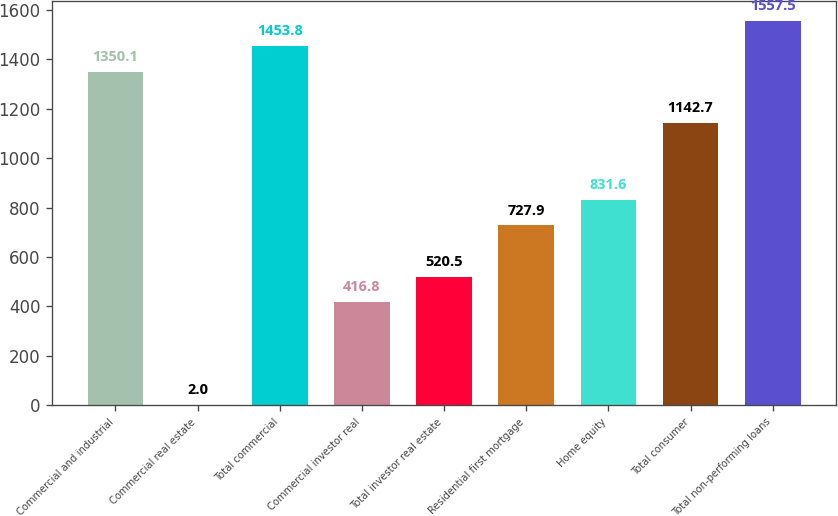Convert chart. <chart><loc_0><loc_0><loc_500><loc_500><bar_chart><fcel>Commercial and industrial<fcel>Commercial real estate<fcel>Total commercial<fcel>Commercial investor real<fcel>Total investor real estate<fcel>Residential first mortgage<fcel>Home equity<fcel>Total consumer<fcel>Total non-performing loans<nl><fcel>1350.1<fcel>2<fcel>1453.8<fcel>416.8<fcel>520.5<fcel>727.9<fcel>831.6<fcel>1142.7<fcel>1557.5<nl></chart> 